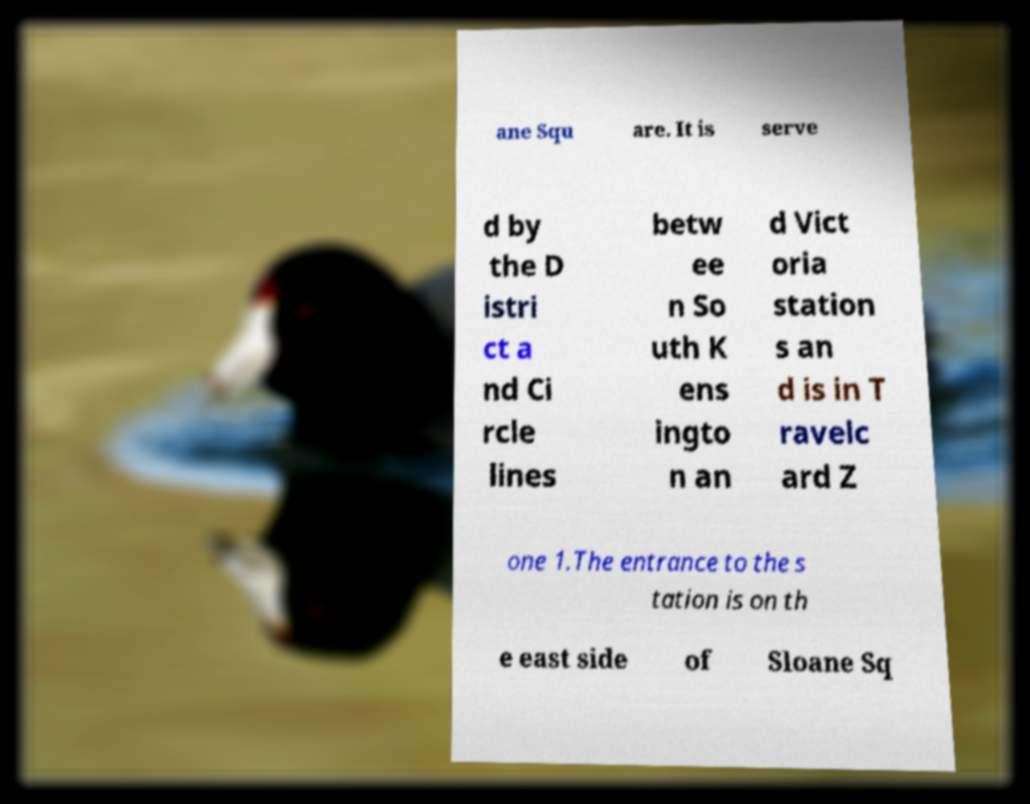Could you extract and type out the text from this image? ane Squ are. It is serve d by the D istri ct a nd Ci rcle lines betw ee n So uth K ens ingto n an d Vict oria station s an d is in T ravelc ard Z one 1.The entrance to the s tation is on th e east side of Sloane Sq 